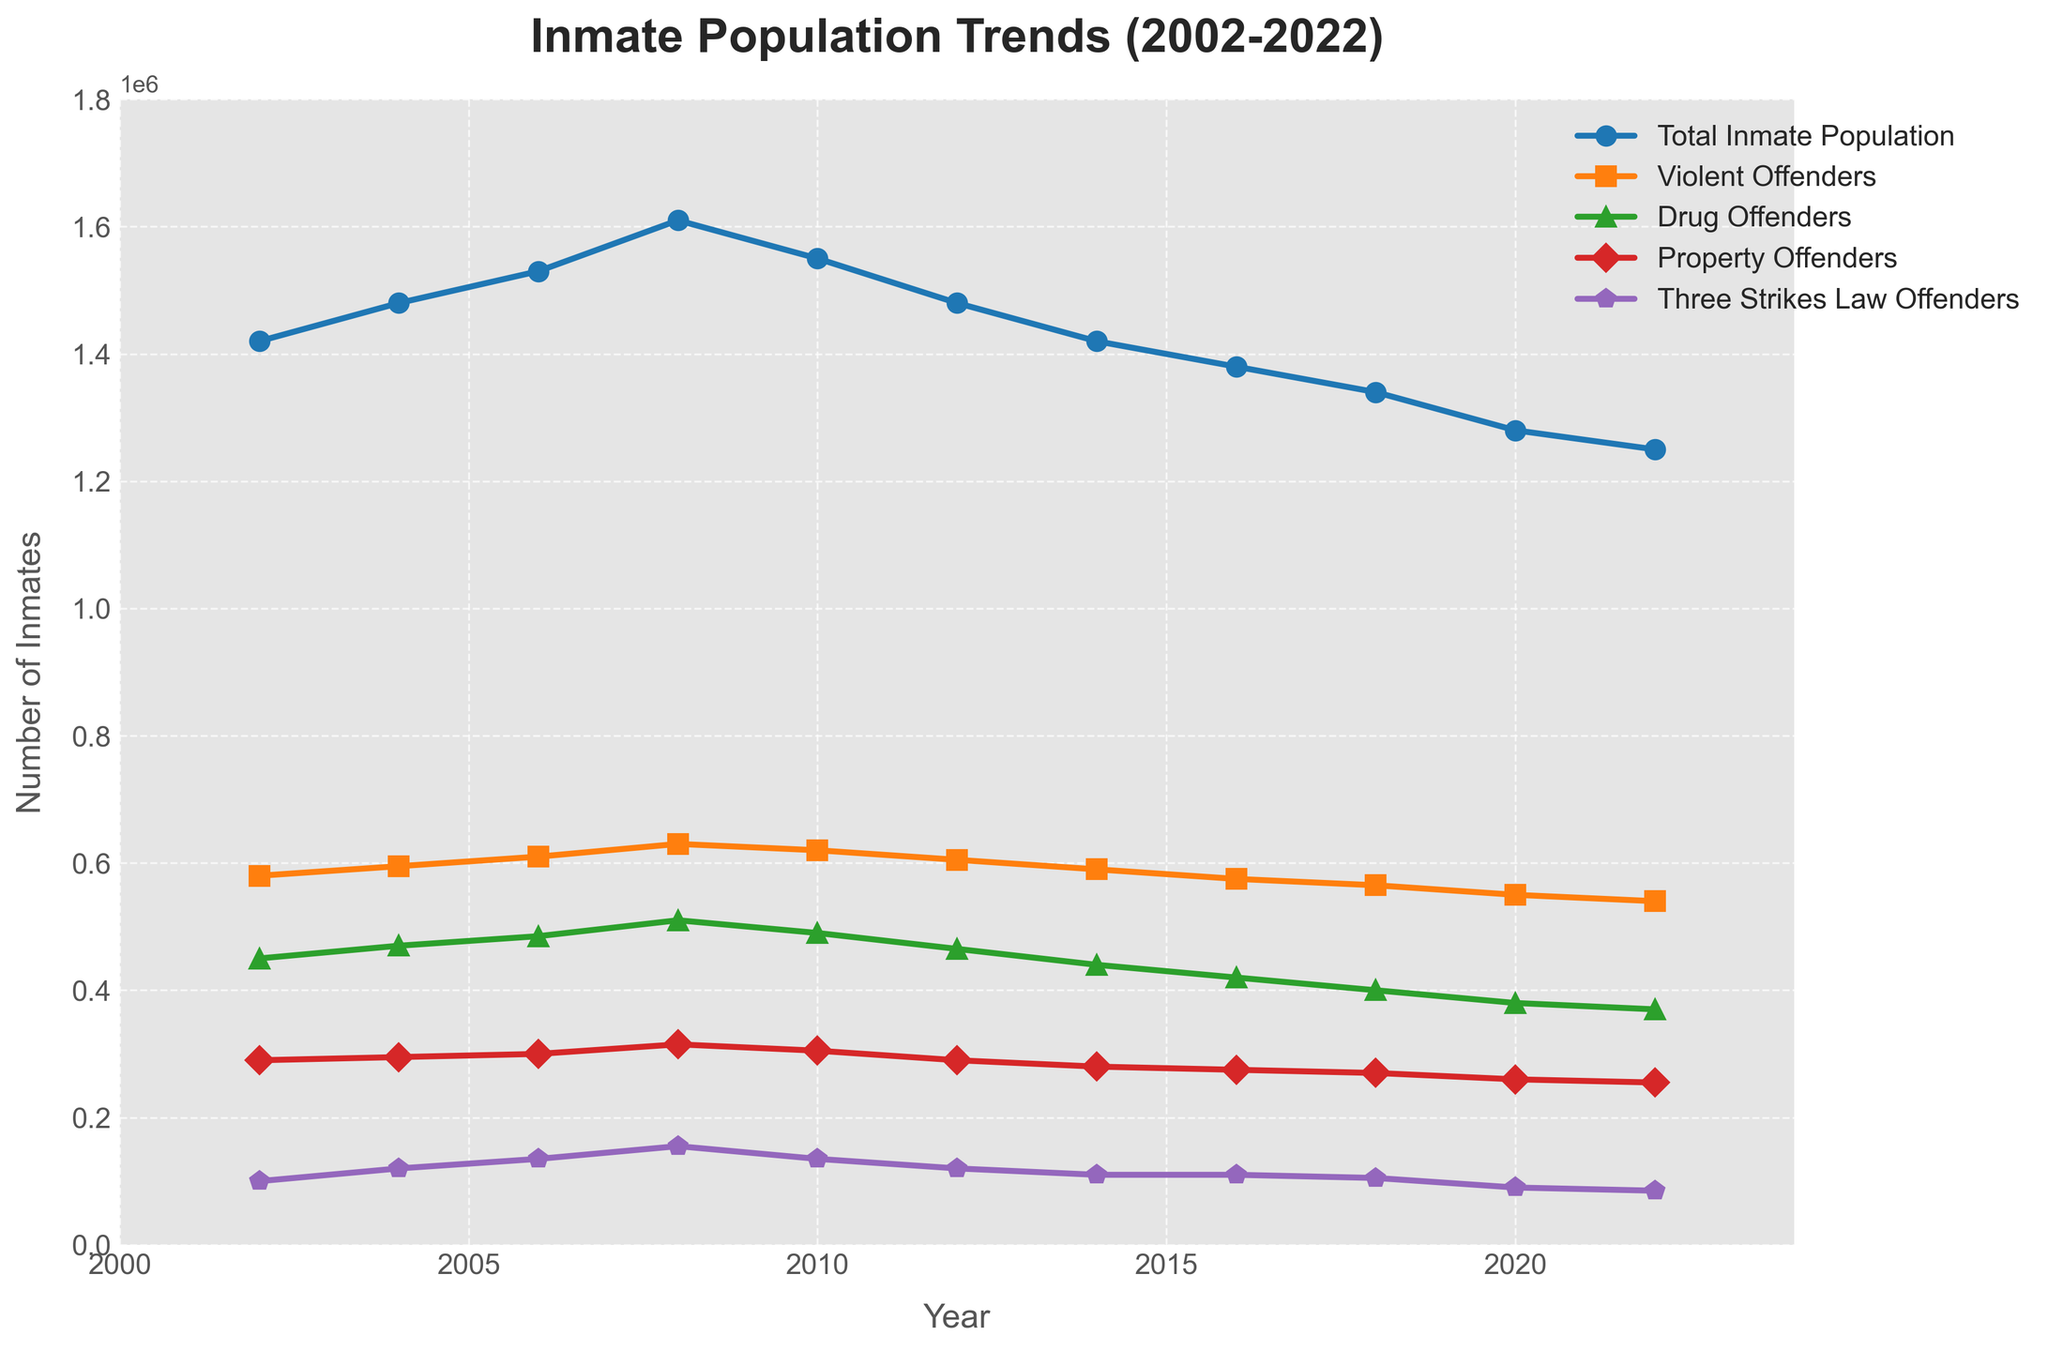What's the trend observed in the Total Inmate Population from 2002 to 2022? By looking at the line representing the Total Inmate Population, we can see an initial increase from 2002 until 2008, followed by a downward trend from 2008 to 2022. Specifically, the population peaks in 2008 and then decreases steadily.
Answer: Initial increase then decrease Which category of offenders saw the most significant decline from 2008 to 2022? The category of Drug Offenders experiences the most significant decline in numbers from 510,000 in 2008 to 370,000 in 2022, which is a reduction of 140,000.
Answer: Drug Offenders By how much did the number of Violent Offenders change from 2002 to 2022? The number of Violent Offenders in 2002 was 580,000, and in 2022 it is 540,000. The change is calculated as 580,000 - 540,000, which results in a decline of 40,000.
Answer: Decreased by 40,000 In which year did the number of Three Strikes Law Offenders peak, and what was the number? By analyzing the graph, the number of Three Strikes Law Offenders peaks in 2008 at 155,000.
Answer: 2008, 155,000 How does the population of Property Offenders in 2022 compare to that in 2010? In 2010, the number of Property Offenders was 305,000, and in 2022 it dropped to 255,000. This indicates a decline of 305,000 - 255,000 = 50,000.
Answer: Decreased by 50,000 Which category consistently had the smallest population from 2002 to 2022? The category of Three Strikes Law Offenders consistently had the smallest population compared to other categories throughout the entire period from 2002 to 2022.
Answer: Three Strikes Law Offenders What was the combined total of Drug and Property Offenders in 2016? In 2016, the number of Drug Offenders was 420,000, and the number of Property Offenders was 275,000. Adding these together gives 420,000 + 275,000 = 695,000.
Answer: 695,000 Which two categories ended up with the closest population numbers in 2022, and what are those numbers? In 2022, Property Offenders numbered 255,000 and Drug Offenders numbered 370,000. The two categories with the closest population numbers are Three Strikes Law Offenders (85,000) and Violent Offenders (540,000), with a difference of 45,000.
Answer: Three Strikes Law Offenders (85,000) and Violent Offenders (540,000) How did the number of Total Inmate Population change from 2002 to 2008? The Total Inmate Population in 2002 was 1,420,000 and in 2008 it was 1,610,000. The change is 1,610,000 - 1,420,000, which results in an increase of 190,000.
Answer: Increased by 190,000 